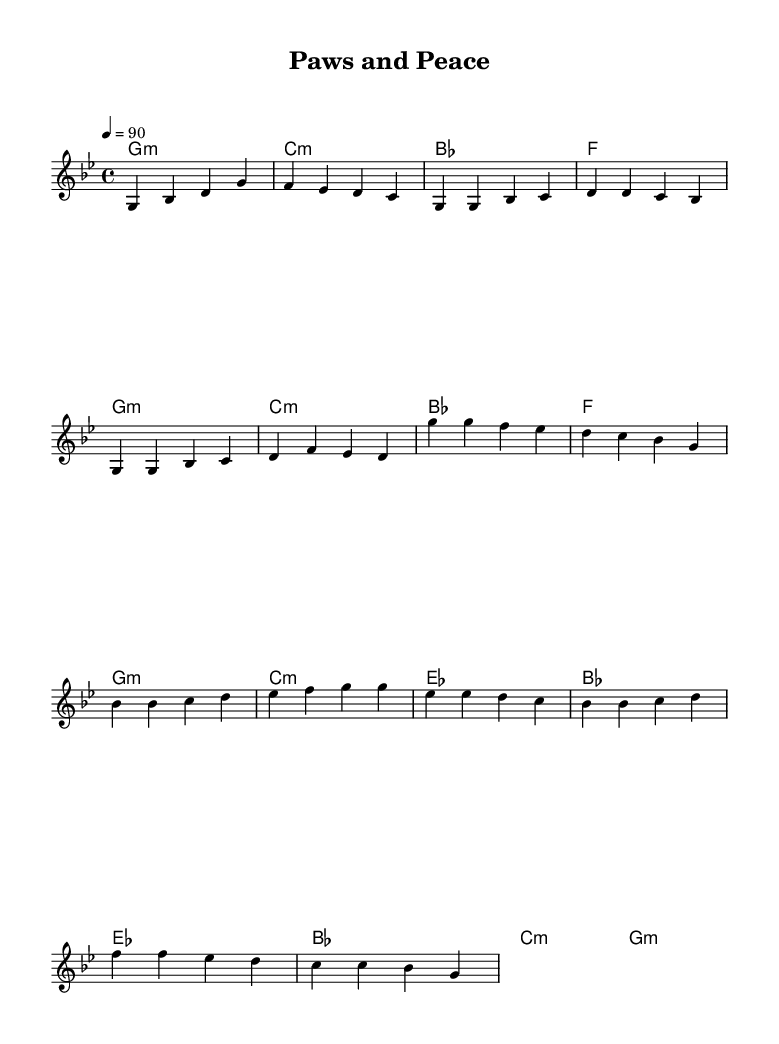What is the key signature of this music? The key signature is G minor, which has two flats (B♭ and E♭). This can be determined from the key indicated in the header and the absence of any accidentals throughout the piece.
Answer: G minor What is the time signature of this music? The time signature is 4/4, which indicates four beats per measure and is largely used in popular music, including hip hop. This is indicated as part of the musical settings in the global block at the beginning of the score.
Answer: 4/4 What is the tempo marking of this music? The tempo marking is 90 BPM (beats per minute), which indicates the speed at which the piece should be played. This is found in the global context where it is specified as "4 = 90."
Answer: 90 How many measures are in the intro section? The intro section has 4 measures, which can be seen by counting the number of groups of notes in the provided melody section before the first verse begins. Each measure has a specific grouping of notes separated by vertical bar lines.
Answer: 4 What chords are used in the chorus? The chords in the chorus are G minor, C minor, E♭ major, and B♭ major, noted in the harmonies section directly underlining the melody for the chorus part.
Answer: G minor, C minor, E♭ major, B♭ major What is unique about the structure of this hip hop anthem? This anthem has a clear structure of verses and a chorus, common in hip hop, which allows for rhythmic speech and vocal delivery over a steady beat, noted by the arrangement of melodies and harmonies subdivided into distinct sections.
Answer: Verses and chorus structure How does the melody progress between the verse and chorus? The melody progresses from a descending motif in the verse to a more uplifting and dynamic feel in the chorus. This can be analyzed by comparing the melodic lines in the melody section under both the verse and chorus labels, observing the shift in note patterns and emotional tone.
Answer: Descending to uplifting 